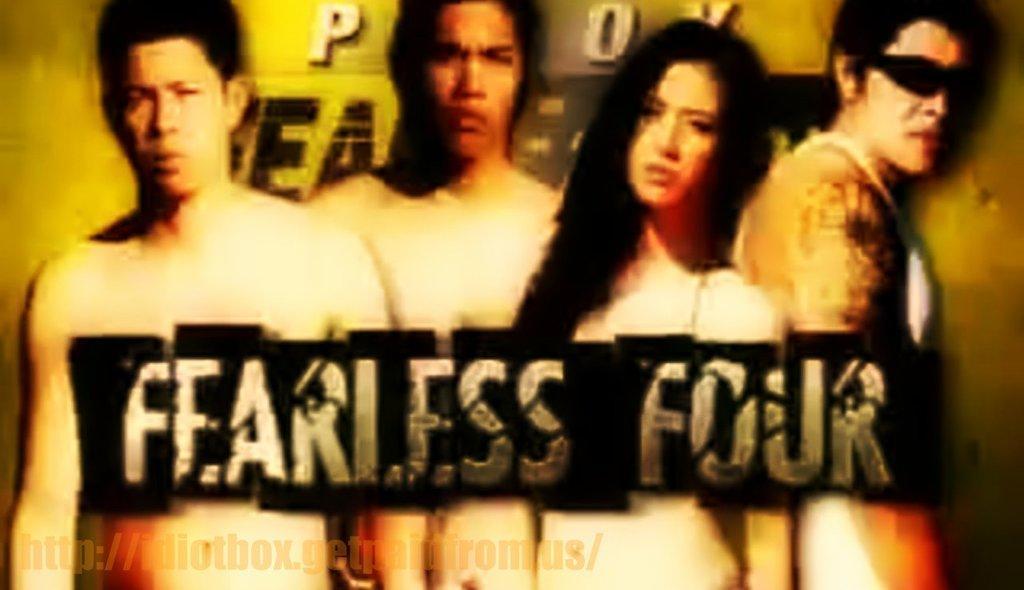Please provide a concise description of this image. In the image we can see a poster, in it there are three men and a woman standing, and the right side man is wearing goggles. Here we can see the text. 